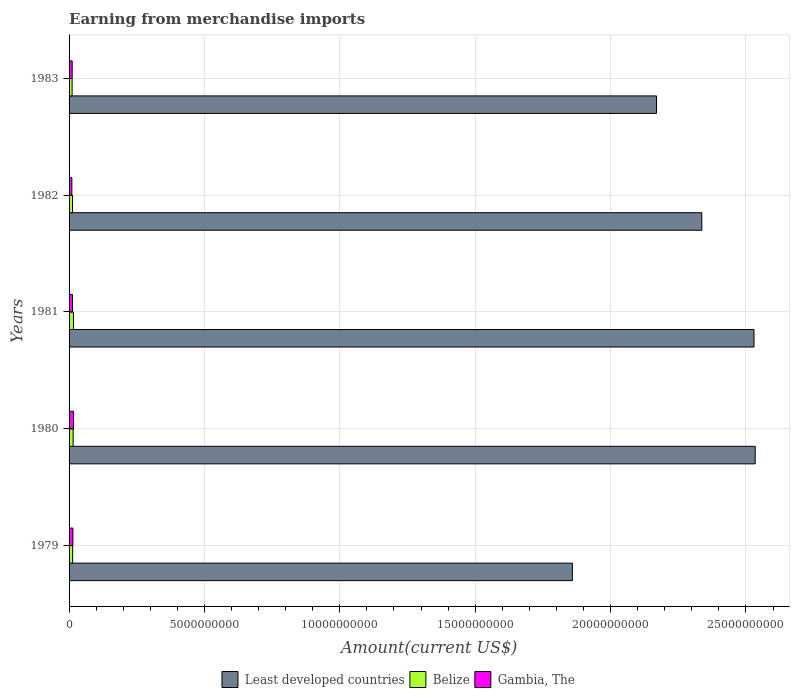Are the number of bars per tick equal to the number of legend labels?
Ensure brevity in your answer.  Yes. Are the number of bars on each tick of the Y-axis equal?
Ensure brevity in your answer.  Yes. How many bars are there on the 2nd tick from the top?
Offer a terse response. 3. How many bars are there on the 4th tick from the bottom?
Make the answer very short. 3. In how many cases, is the number of bars for a given year not equal to the number of legend labels?
Offer a terse response. 0. What is the amount earned from merchandise imports in Belize in 1982?
Make the answer very short. 1.28e+08. Across all years, what is the maximum amount earned from merchandise imports in Gambia, The?
Offer a very short reply. 1.65e+08. Across all years, what is the minimum amount earned from merchandise imports in Gambia, The?
Offer a very short reply. 1.03e+08. What is the total amount earned from merchandise imports in Least developed countries in the graph?
Offer a terse response. 1.14e+11. What is the difference between the amount earned from merchandise imports in Belize in 1979 and that in 1980?
Ensure brevity in your answer.  -1.82e+07. What is the average amount earned from merchandise imports in Gambia, The per year?
Your answer should be very brief. 1.30e+08. In the year 1981, what is the difference between the amount earned from merchandise imports in Gambia, The and amount earned from merchandise imports in Least developed countries?
Keep it short and to the point. -2.52e+1. In how many years, is the amount earned from merchandise imports in Least developed countries greater than 9000000000 US$?
Make the answer very short. 5. What is the ratio of the amount earned from merchandise imports in Gambia, The in 1979 to that in 1982?
Your answer should be very brief. 1.37. Is the difference between the amount earned from merchandise imports in Gambia, The in 1981 and 1982 greater than the difference between the amount earned from merchandise imports in Least developed countries in 1981 and 1982?
Provide a succinct answer. No. What is the difference between the highest and the second highest amount earned from merchandise imports in Least developed countries?
Offer a terse response. 4.30e+07. What is the difference between the highest and the lowest amount earned from merchandise imports in Least developed countries?
Your answer should be very brief. 6.75e+09. In how many years, is the amount earned from merchandise imports in Belize greater than the average amount earned from merchandise imports in Belize taken over all years?
Offer a very short reply. 2. Is the sum of the amount earned from merchandise imports in Least developed countries in 1979 and 1983 greater than the maximum amount earned from merchandise imports in Belize across all years?
Ensure brevity in your answer.  Yes. What does the 2nd bar from the top in 1982 represents?
Make the answer very short. Belize. What does the 1st bar from the bottom in 1980 represents?
Your answer should be very brief. Least developed countries. Is it the case that in every year, the sum of the amount earned from merchandise imports in Least developed countries and amount earned from merchandise imports in Gambia, The is greater than the amount earned from merchandise imports in Belize?
Offer a terse response. Yes. Are all the bars in the graph horizontal?
Ensure brevity in your answer.  Yes. How many years are there in the graph?
Keep it short and to the point. 5. What is the difference between two consecutive major ticks on the X-axis?
Provide a short and direct response. 5.00e+09. Does the graph contain grids?
Make the answer very short. Yes. Where does the legend appear in the graph?
Make the answer very short. Bottom center. How many legend labels are there?
Offer a terse response. 3. What is the title of the graph?
Your answer should be compact. Earning from merchandise imports. Does "Jordan" appear as one of the legend labels in the graph?
Make the answer very short. No. What is the label or title of the X-axis?
Make the answer very short. Amount(current US$). What is the Amount(current US$) of Least developed countries in 1979?
Keep it short and to the point. 1.86e+1. What is the Amount(current US$) of Belize in 1979?
Your response must be concise. 1.32e+08. What is the Amount(current US$) in Gambia, The in 1979?
Give a very brief answer. 1.41e+08. What is the Amount(current US$) of Least developed countries in 1980?
Keep it short and to the point. 2.53e+1. What is the Amount(current US$) of Belize in 1980?
Provide a succinct answer. 1.50e+08. What is the Amount(current US$) of Gambia, The in 1980?
Your answer should be compact. 1.65e+08. What is the Amount(current US$) of Least developed countries in 1981?
Your answer should be compact. 2.53e+1. What is the Amount(current US$) of Belize in 1981?
Your answer should be very brief. 1.62e+08. What is the Amount(current US$) in Gambia, The in 1981?
Offer a terse response. 1.26e+08. What is the Amount(current US$) in Least developed countries in 1982?
Make the answer very short. 2.34e+1. What is the Amount(current US$) in Belize in 1982?
Make the answer very short. 1.28e+08. What is the Amount(current US$) of Gambia, The in 1982?
Your answer should be very brief. 1.03e+08. What is the Amount(current US$) in Least developed countries in 1983?
Make the answer very short. 2.17e+1. What is the Amount(current US$) in Belize in 1983?
Ensure brevity in your answer.  1.12e+08. What is the Amount(current US$) of Gambia, The in 1983?
Give a very brief answer. 1.15e+08. Across all years, what is the maximum Amount(current US$) in Least developed countries?
Provide a short and direct response. 2.53e+1. Across all years, what is the maximum Amount(current US$) in Belize?
Provide a short and direct response. 1.62e+08. Across all years, what is the maximum Amount(current US$) in Gambia, The?
Your answer should be very brief. 1.65e+08. Across all years, what is the minimum Amount(current US$) in Least developed countries?
Offer a very short reply. 1.86e+1. Across all years, what is the minimum Amount(current US$) in Belize?
Provide a short and direct response. 1.12e+08. Across all years, what is the minimum Amount(current US$) in Gambia, The?
Offer a terse response. 1.03e+08. What is the total Amount(current US$) of Least developed countries in the graph?
Offer a terse response. 1.14e+11. What is the total Amount(current US$) of Belize in the graph?
Give a very brief answer. 6.84e+08. What is the total Amount(current US$) in Gambia, The in the graph?
Keep it short and to the point. 6.50e+08. What is the difference between the Amount(current US$) in Least developed countries in 1979 and that in 1980?
Make the answer very short. -6.75e+09. What is the difference between the Amount(current US$) in Belize in 1979 and that in 1980?
Ensure brevity in your answer.  -1.82e+07. What is the difference between the Amount(current US$) in Gambia, The in 1979 and that in 1980?
Offer a very short reply. -2.38e+07. What is the difference between the Amount(current US$) in Least developed countries in 1979 and that in 1981?
Provide a short and direct response. -6.71e+09. What is the difference between the Amount(current US$) in Belize in 1979 and that in 1981?
Offer a very short reply. -3.02e+07. What is the difference between the Amount(current US$) of Gambia, The in 1979 and that in 1981?
Provide a succinct answer. 1.52e+07. What is the difference between the Amount(current US$) in Least developed countries in 1979 and that in 1982?
Offer a terse response. -4.78e+09. What is the difference between the Amount(current US$) of Belize in 1979 and that in 1982?
Keep it short and to the point. 3.84e+06. What is the difference between the Amount(current US$) in Gambia, The in 1979 and that in 1982?
Give a very brief answer. 3.82e+07. What is the difference between the Amount(current US$) of Least developed countries in 1979 and that in 1983?
Your answer should be very brief. -3.11e+09. What is the difference between the Amount(current US$) in Belize in 1979 and that in 1983?
Your answer should be very brief. 1.98e+07. What is the difference between the Amount(current US$) of Gambia, The in 1979 and that in 1983?
Offer a very short reply. 2.62e+07. What is the difference between the Amount(current US$) in Least developed countries in 1980 and that in 1981?
Offer a terse response. 4.30e+07. What is the difference between the Amount(current US$) in Belize in 1980 and that in 1981?
Make the answer very short. -1.20e+07. What is the difference between the Amount(current US$) in Gambia, The in 1980 and that in 1981?
Keep it short and to the point. 3.90e+07. What is the difference between the Amount(current US$) of Least developed countries in 1980 and that in 1982?
Make the answer very short. 1.97e+09. What is the difference between the Amount(current US$) of Belize in 1980 and that in 1982?
Offer a very short reply. 2.20e+07. What is the difference between the Amount(current US$) in Gambia, The in 1980 and that in 1982?
Offer a terse response. 6.20e+07. What is the difference between the Amount(current US$) of Least developed countries in 1980 and that in 1983?
Your answer should be very brief. 3.64e+09. What is the difference between the Amount(current US$) in Belize in 1980 and that in 1983?
Offer a very short reply. 3.80e+07. What is the difference between the Amount(current US$) in Least developed countries in 1981 and that in 1982?
Your answer should be very brief. 1.93e+09. What is the difference between the Amount(current US$) in Belize in 1981 and that in 1982?
Your answer should be very brief. 3.40e+07. What is the difference between the Amount(current US$) of Gambia, The in 1981 and that in 1982?
Provide a succinct answer. 2.30e+07. What is the difference between the Amount(current US$) in Least developed countries in 1981 and that in 1983?
Ensure brevity in your answer.  3.60e+09. What is the difference between the Amount(current US$) of Gambia, The in 1981 and that in 1983?
Give a very brief answer. 1.10e+07. What is the difference between the Amount(current US$) in Least developed countries in 1982 and that in 1983?
Your answer should be very brief. 1.67e+09. What is the difference between the Amount(current US$) in Belize in 1982 and that in 1983?
Your answer should be compact. 1.60e+07. What is the difference between the Amount(current US$) of Gambia, The in 1982 and that in 1983?
Provide a succinct answer. -1.20e+07. What is the difference between the Amount(current US$) of Least developed countries in 1979 and the Amount(current US$) of Belize in 1980?
Offer a very short reply. 1.84e+1. What is the difference between the Amount(current US$) in Least developed countries in 1979 and the Amount(current US$) in Gambia, The in 1980?
Your response must be concise. 1.84e+1. What is the difference between the Amount(current US$) in Belize in 1979 and the Amount(current US$) in Gambia, The in 1980?
Your answer should be very brief. -3.32e+07. What is the difference between the Amount(current US$) in Least developed countries in 1979 and the Amount(current US$) in Belize in 1981?
Your answer should be very brief. 1.84e+1. What is the difference between the Amount(current US$) in Least developed countries in 1979 and the Amount(current US$) in Gambia, The in 1981?
Keep it short and to the point. 1.85e+1. What is the difference between the Amount(current US$) in Belize in 1979 and the Amount(current US$) in Gambia, The in 1981?
Ensure brevity in your answer.  5.84e+06. What is the difference between the Amount(current US$) in Least developed countries in 1979 and the Amount(current US$) in Belize in 1982?
Your answer should be very brief. 1.85e+1. What is the difference between the Amount(current US$) of Least developed countries in 1979 and the Amount(current US$) of Gambia, The in 1982?
Your response must be concise. 1.85e+1. What is the difference between the Amount(current US$) of Belize in 1979 and the Amount(current US$) of Gambia, The in 1982?
Your response must be concise. 2.88e+07. What is the difference between the Amount(current US$) of Least developed countries in 1979 and the Amount(current US$) of Belize in 1983?
Ensure brevity in your answer.  1.85e+1. What is the difference between the Amount(current US$) of Least developed countries in 1979 and the Amount(current US$) of Gambia, The in 1983?
Keep it short and to the point. 1.85e+1. What is the difference between the Amount(current US$) in Belize in 1979 and the Amount(current US$) in Gambia, The in 1983?
Give a very brief answer. 1.68e+07. What is the difference between the Amount(current US$) in Least developed countries in 1980 and the Amount(current US$) in Belize in 1981?
Ensure brevity in your answer.  2.52e+1. What is the difference between the Amount(current US$) of Least developed countries in 1980 and the Amount(current US$) of Gambia, The in 1981?
Provide a short and direct response. 2.52e+1. What is the difference between the Amount(current US$) of Belize in 1980 and the Amount(current US$) of Gambia, The in 1981?
Your answer should be compact. 2.40e+07. What is the difference between the Amount(current US$) in Least developed countries in 1980 and the Amount(current US$) in Belize in 1982?
Provide a short and direct response. 2.52e+1. What is the difference between the Amount(current US$) of Least developed countries in 1980 and the Amount(current US$) of Gambia, The in 1982?
Make the answer very short. 2.52e+1. What is the difference between the Amount(current US$) in Belize in 1980 and the Amount(current US$) in Gambia, The in 1982?
Provide a short and direct response. 4.70e+07. What is the difference between the Amount(current US$) in Least developed countries in 1980 and the Amount(current US$) in Belize in 1983?
Your answer should be very brief. 2.52e+1. What is the difference between the Amount(current US$) in Least developed countries in 1980 and the Amount(current US$) in Gambia, The in 1983?
Provide a short and direct response. 2.52e+1. What is the difference between the Amount(current US$) of Belize in 1980 and the Amount(current US$) of Gambia, The in 1983?
Your answer should be very brief. 3.50e+07. What is the difference between the Amount(current US$) of Least developed countries in 1981 and the Amount(current US$) of Belize in 1982?
Give a very brief answer. 2.52e+1. What is the difference between the Amount(current US$) in Least developed countries in 1981 and the Amount(current US$) in Gambia, The in 1982?
Provide a short and direct response. 2.52e+1. What is the difference between the Amount(current US$) in Belize in 1981 and the Amount(current US$) in Gambia, The in 1982?
Your response must be concise. 5.90e+07. What is the difference between the Amount(current US$) of Least developed countries in 1981 and the Amount(current US$) of Belize in 1983?
Your answer should be compact. 2.52e+1. What is the difference between the Amount(current US$) of Least developed countries in 1981 and the Amount(current US$) of Gambia, The in 1983?
Give a very brief answer. 2.52e+1. What is the difference between the Amount(current US$) of Belize in 1981 and the Amount(current US$) of Gambia, The in 1983?
Your response must be concise. 4.70e+07. What is the difference between the Amount(current US$) of Least developed countries in 1982 and the Amount(current US$) of Belize in 1983?
Give a very brief answer. 2.33e+1. What is the difference between the Amount(current US$) in Least developed countries in 1982 and the Amount(current US$) in Gambia, The in 1983?
Make the answer very short. 2.33e+1. What is the difference between the Amount(current US$) in Belize in 1982 and the Amount(current US$) in Gambia, The in 1983?
Ensure brevity in your answer.  1.30e+07. What is the average Amount(current US$) of Least developed countries per year?
Keep it short and to the point. 2.29e+1. What is the average Amount(current US$) of Belize per year?
Your answer should be very brief. 1.37e+08. What is the average Amount(current US$) in Gambia, The per year?
Keep it short and to the point. 1.30e+08. In the year 1979, what is the difference between the Amount(current US$) of Least developed countries and Amount(current US$) of Belize?
Provide a short and direct response. 1.85e+1. In the year 1979, what is the difference between the Amount(current US$) in Least developed countries and Amount(current US$) in Gambia, The?
Ensure brevity in your answer.  1.84e+1. In the year 1979, what is the difference between the Amount(current US$) in Belize and Amount(current US$) in Gambia, The?
Provide a short and direct response. -9.35e+06. In the year 1980, what is the difference between the Amount(current US$) in Least developed countries and Amount(current US$) in Belize?
Your answer should be compact. 2.52e+1. In the year 1980, what is the difference between the Amount(current US$) in Least developed countries and Amount(current US$) in Gambia, The?
Your answer should be compact. 2.52e+1. In the year 1980, what is the difference between the Amount(current US$) in Belize and Amount(current US$) in Gambia, The?
Keep it short and to the point. -1.50e+07. In the year 1981, what is the difference between the Amount(current US$) in Least developed countries and Amount(current US$) in Belize?
Your response must be concise. 2.51e+1. In the year 1981, what is the difference between the Amount(current US$) in Least developed countries and Amount(current US$) in Gambia, The?
Your response must be concise. 2.52e+1. In the year 1981, what is the difference between the Amount(current US$) of Belize and Amount(current US$) of Gambia, The?
Make the answer very short. 3.60e+07. In the year 1982, what is the difference between the Amount(current US$) of Least developed countries and Amount(current US$) of Belize?
Keep it short and to the point. 2.32e+1. In the year 1982, what is the difference between the Amount(current US$) of Least developed countries and Amount(current US$) of Gambia, The?
Your response must be concise. 2.33e+1. In the year 1982, what is the difference between the Amount(current US$) of Belize and Amount(current US$) of Gambia, The?
Ensure brevity in your answer.  2.50e+07. In the year 1983, what is the difference between the Amount(current US$) in Least developed countries and Amount(current US$) in Belize?
Give a very brief answer. 2.16e+1. In the year 1983, what is the difference between the Amount(current US$) of Least developed countries and Amount(current US$) of Gambia, The?
Your response must be concise. 2.16e+1. In the year 1983, what is the difference between the Amount(current US$) in Belize and Amount(current US$) in Gambia, The?
Provide a succinct answer. -3.00e+06. What is the ratio of the Amount(current US$) in Least developed countries in 1979 to that in 1980?
Your answer should be very brief. 0.73. What is the ratio of the Amount(current US$) of Belize in 1979 to that in 1980?
Provide a succinct answer. 0.88. What is the ratio of the Amount(current US$) of Gambia, The in 1979 to that in 1980?
Provide a succinct answer. 0.86. What is the ratio of the Amount(current US$) in Least developed countries in 1979 to that in 1981?
Ensure brevity in your answer.  0.73. What is the ratio of the Amount(current US$) of Belize in 1979 to that in 1981?
Your response must be concise. 0.81. What is the ratio of the Amount(current US$) of Gambia, The in 1979 to that in 1981?
Make the answer very short. 1.12. What is the ratio of the Amount(current US$) in Least developed countries in 1979 to that in 1982?
Offer a very short reply. 0.8. What is the ratio of the Amount(current US$) in Gambia, The in 1979 to that in 1982?
Keep it short and to the point. 1.37. What is the ratio of the Amount(current US$) in Least developed countries in 1979 to that in 1983?
Offer a terse response. 0.86. What is the ratio of the Amount(current US$) in Belize in 1979 to that in 1983?
Provide a short and direct response. 1.18. What is the ratio of the Amount(current US$) of Gambia, The in 1979 to that in 1983?
Provide a short and direct response. 1.23. What is the ratio of the Amount(current US$) in Least developed countries in 1980 to that in 1981?
Ensure brevity in your answer.  1. What is the ratio of the Amount(current US$) in Belize in 1980 to that in 1981?
Offer a terse response. 0.93. What is the ratio of the Amount(current US$) in Gambia, The in 1980 to that in 1981?
Ensure brevity in your answer.  1.31. What is the ratio of the Amount(current US$) in Least developed countries in 1980 to that in 1982?
Make the answer very short. 1.08. What is the ratio of the Amount(current US$) of Belize in 1980 to that in 1982?
Your answer should be compact. 1.17. What is the ratio of the Amount(current US$) in Gambia, The in 1980 to that in 1982?
Your answer should be very brief. 1.6. What is the ratio of the Amount(current US$) of Least developed countries in 1980 to that in 1983?
Offer a very short reply. 1.17. What is the ratio of the Amount(current US$) in Belize in 1980 to that in 1983?
Offer a terse response. 1.34. What is the ratio of the Amount(current US$) in Gambia, The in 1980 to that in 1983?
Offer a very short reply. 1.43. What is the ratio of the Amount(current US$) in Least developed countries in 1981 to that in 1982?
Keep it short and to the point. 1.08. What is the ratio of the Amount(current US$) of Belize in 1981 to that in 1982?
Your response must be concise. 1.27. What is the ratio of the Amount(current US$) in Gambia, The in 1981 to that in 1982?
Offer a very short reply. 1.22. What is the ratio of the Amount(current US$) in Least developed countries in 1981 to that in 1983?
Offer a terse response. 1.17. What is the ratio of the Amount(current US$) in Belize in 1981 to that in 1983?
Make the answer very short. 1.45. What is the ratio of the Amount(current US$) of Gambia, The in 1981 to that in 1983?
Keep it short and to the point. 1.1. What is the ratio of the Amount(current US$) in Least developed countries in 1982 to that in 1983?
Provide a short and direct response. 1.08. What is the ratio of the Amount(current US$) of Belize in 1982 to that in 1983?
Keep it short and to the point. 1.14. What is the ratio of the Amount(current US$) of Gambia, The in 1982 to that in 1983?
Give a very brief answer. 0.9. What is the difference between the highest and the second highest Amount(current US$) in Least developed countries?
Provide a succinct answer. 4.30e+07. What is the difference between the highest and the second highest Amount(current US$) of Gambia, The?
Your answer should be compact. 2.38e+07. What is the difference between the highest and the lowest Amount(current US$) in Least developed countries?
Your answer should be compact. 6.75e+09. What is the difference between the highest and the lowest Amount(current US$) of Belize?
Make the answer very short. 5.00e+07. What is the difference between the highest and the lowest Amount(current US$) of Gambia, The?
Offer a terse response. 6.20e+07. 